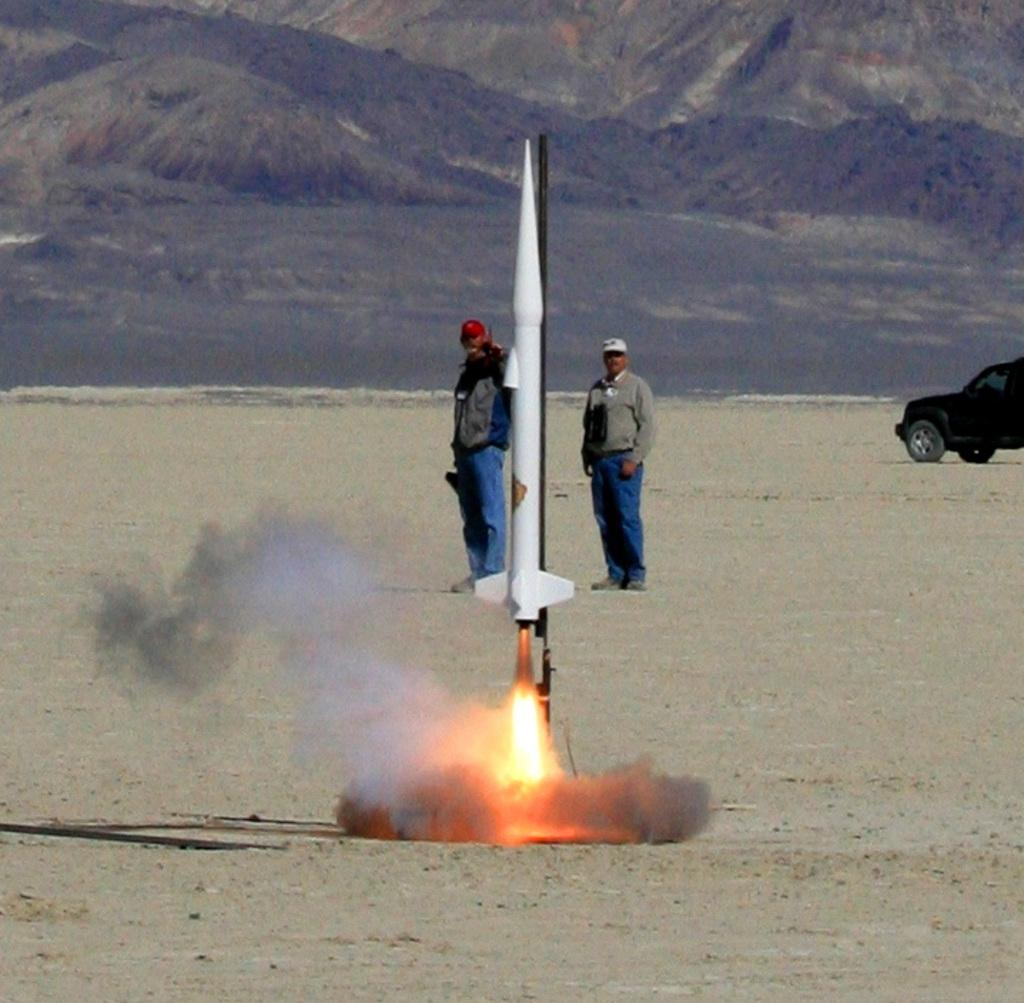What is the main subject of the image? The main subject of the image is a rocket with fire. Can you describe the people in the image? There are two persons standing in the image. What else can be seen on the right side of the image? There is a vehicle on the right side of the image. What is visible in the background of the image? There are hills visible in the background of the image. What type of trains can be seen in the image? There are no trains present in the image. How many balls are visible in the image? There are no balls visible in the image. 